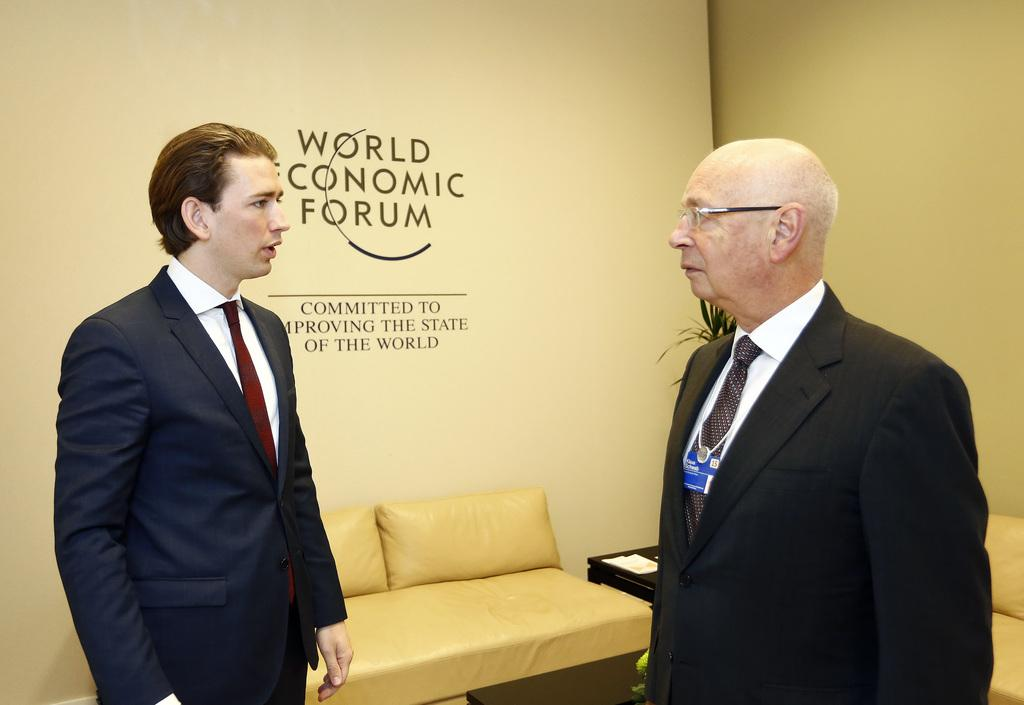How many people are in the image? There are two persons standing in the image. What is the surface they are standing on? The persons are standing on the floor. What type of furniture is present in the image? There is a sofa in the image. What is the background of the image? There is a wall in the image. What type of natural element can be seen in the image? There is a tree visible in the image. What type of music is being played by the tree in the image? There is no music being played by the tree in the image, as trees do not have the ability to play music. 